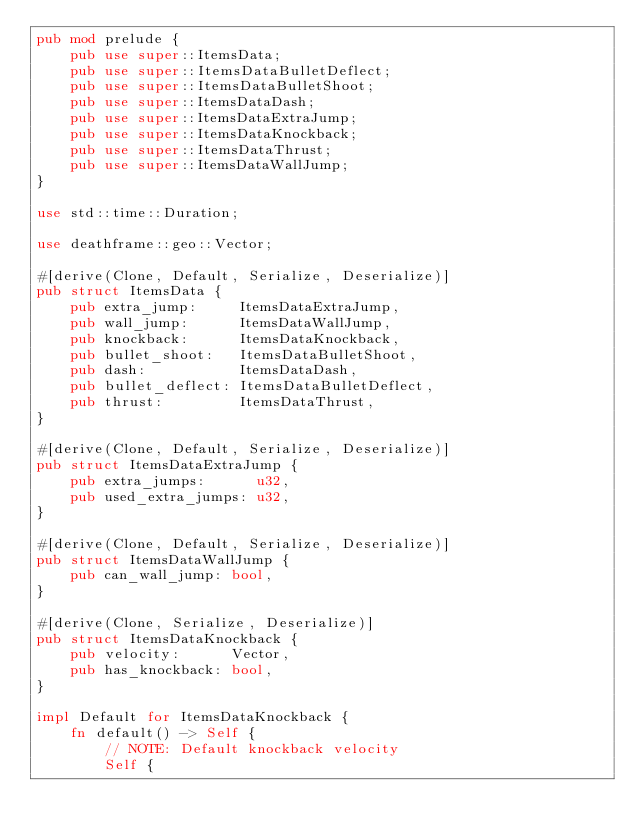<code> <loc_0><loc_0><loc_500><loc_500><_Rust_>pub mod prelude {
    pub use super::ItemsData;
    pub use super::ItemsDataBulletDeflect;
    pub use super::ItemsDataBulletShoot;
    pub use super::ItemsDataDash;
    pub use super::ItemsDataExtraJump;
    pub use super::ItemsDataKnockback;
    pub use super::ItemsDataThrust;
    pub use super::ItemsDataWallJump;
}

use std::time::Duration;

use deathframe::geo::Vector;

#[derive(Clone, Default, Serialize, Deserialize)]
pub struct ItemsData {
    pub extra_jump:     ItemsDataExtraJump,
    pub wall_jump:      ItemsDataWallJump,
    pub knockback:      ItemsDataKnockback,
    pub bullet_shoot:   ItemsDataBulletShoot,
    pub dash:           ItemsDataDash,
    pub bullet_deflect: ItemsDataBulletDeflect,
    pub thrust:         ItemsDataThrust,
}

#[derive(Clone, Default, Serialize, Deserialize)]
pub struct ItemsDataExtraJump {
    pub extra_jumps:      u32,
    pub used_extra_jumps: u32,
}

#[derive(Clone, Default, Serialize, Deserialize)]
pub struct ItemsDataWallJump {
    pub can_wall_jump: bool,
}

#[derive(Clone, Serialize, Deserialize)]
pub struct ItemsDataKnockback {
    pub velocity:      Vector,
    pub has_knockback: bool,
}

impl Default for ItemsDataKnockback {
    fn default() -> Self {
        // NOTE: Default knockback velocity
        Self {</code> 